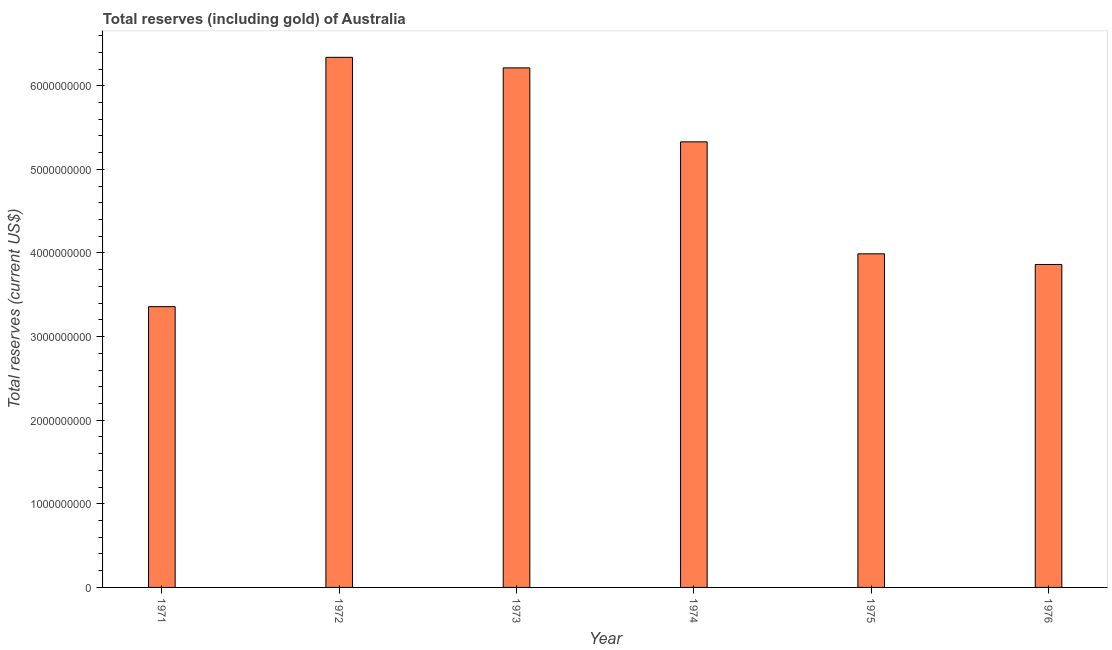What is the title of the graph?
Your answer should be very brief. Total reserves (including gold) of Australia. What is the label or title of the Y-axis?
Offer a very short reply. Total reserves (current US$). What is the total reserves (including gold) in 1971?
Provide a short and direct response. 3.36e+09. Across all years, what is the maximum total reserves (including gold)?
Your response must be concise. 6.34e+09. Across all years, what is the minimum total reserves (including gold)?
Offer a terse response. 3.36e+09. What is the sum of the total reserves (including gold)?
Offer a terse response. 2.91e+1. What is the difference between the total reserves (including gold) in 1972 and 1973?
Your answer should be very brief. 1.26e+08. What is the average total reserves (including gold) per year?
Your response must be concise. 4.85e+09. What is the median total reserves (including gold)?
Offer a terse response. 4.66e+09. What is the ratio of the total reserves (including gold) in 1971 to that in 1976?
Keep it short and to the point. 0.87. What is the difference between the highest and the second highest total reserves (including gold)?
Ensure brevity in your answer.  1.26e+08. What is the difference between the highest and the lowest total reserves (including gold)?
Provide a succinct answer. 2.98e+09. In how many years, is the total reserves (including gold) greater than the average total reserves (including gold) taken over all years?
Make the answer very short. 3. Are all the bars in the graph horizontal?
Provide a short and direct response. No. How many years are there in the graph?
Offer a very short reply. 6. What is the difference between two consecutive major ticks on the Y-axis?
Offer a terse response. 1.00e+09. Are the values on the major ticks of Y-axis written in scientific E-notation?
Make the answer very short. No. What is the Total reserves (current US$) in 1971?
Your answer should be very brief. 3.36e+09. What is the Total reserves (current US$) in 1972?
Offer a very short reply. 6.34e+09. What is the Total reserves (current US$) of 1973?
Provide a succinct answer. 6.21e+09. What is the Total reserves (current US$) in 1974?
Offer a terse response. 5.33e+09. What is the Total reserves (current US$) of 1975?
Provide a short and direct response. 3.99e+09. What is the Total reserves (current US$) of 1976?
Make the answer very short. 3.86e+09. What is the difference between the Total reserves (current US$) in 1971 and 1972?
Provide a succinct answer. -2.98e+09. What is the difference between the Total reserves (current US$) in 1971 and 1973?
Keep it short and to the point. -2.86e+09. What is the difference between the Total reserves (current US$) in 1971 and 1974?
Offer a very short reply. -1.97e+09. What is the difference between the Total reserves (current US$) in 1971 and 1975?
Offer a very short reply. -6.32e+08. What is the difference between the Total reserves (current US$) in 1971 and 1976?
Keep it short and to the point. -5.04e+08. What is the difference between the Total reserves (current US$) in 1972 and 1973?
Keep it short and to the point. 1.26e+08. What is the difference between the Total reserves (current US$) in 1972 and 1974?
Your answer should be compact. 1.01e+09. What is the difference between the Total reserves (current US$) in 1972 and 1975?
Ensure brevity in your answer.  2.35e+09. What is the difference between the Total reserves (current US$) in 1972 and 1976?
Provide a short and direct response. 2.48e+09. What is the difference between the Total reserves (current US$) in 1973 and 1974?
Keep it short and to the point. 8.85e+08. What is the difference between the Total reserves (current US$) in 1973 and 1975?
Your response must be concise. 2.22e+09. What is the difference between the Total reserves (current US$) in 1973 and 1976?
Provide a short and direct response. 2.35e+09. What is the difference between the Total reserves (current US$) in 1974 and 1975?
Your answer should be compact. 1.34e+09. What is the difference between the Total reserves (current US$) in 1974 and 1976?
Keep it short and to the point. 1.47e+09. What is the difference between the Total reserves (current US$) in 1975 and 1976?
Provide a succinct answer. 1.28e+08. What is the ratio of the Total reserves (current US$) in 1971 to that in 1972?
Offer a very short reply. 0.53. What is the ratio of the Total reserves (current US$) in 1971 to that in 1973?
Your response must be concise. 0.54. What is the ratio of the Total reserves (current US$) in 1971 to that in 1974?
Ensure brevity in your answer.  0.63. What is the ratio of the Total reserves (current US$) in 1971 to that in 1975?
Your answer should be compact. 0.84. What is the ratio of the Total reserves (current US$) in 1971 to that in 1976?
Make the answer very short. 0.87. What is the ratio of the Total reserves (current US$) in 1972 to that in 1974?
Your answer should be compact. 1.19. What is the ratio of the Total reserves (current US$) in 1972 to that in 1975?
Your response must be concise. 1.59. What is the ratio of the Total reserves (current US$) in 1972 to that in 1976?
Offer a terse response. 1.64. What is the ratio of the Total reserves (current US$) in 1973 to that in 1974?
Provide a succinct answer. 1.17. What is the ratio of the Total reserves (current US$) in 1973 to that in 1975?
Provide a short and direct response. 1.56. What is the ratio of the Total reserves (current US$) in 1973 to that in 1976?
Provide a succinct answer. 1.61. What is the ratio of the Total reserves (current US$) in 1974 to that in 1975?
Your answer should be compact. 1.34. What is the ratio of the Total reserves (current US$) in 1974 to that in 1976?
Provide a succinct answer. 1.38. What is the ratio of the Total reserves (current US$) in 1975 to that in 1976?
Your answer should be compact. 1.03. 